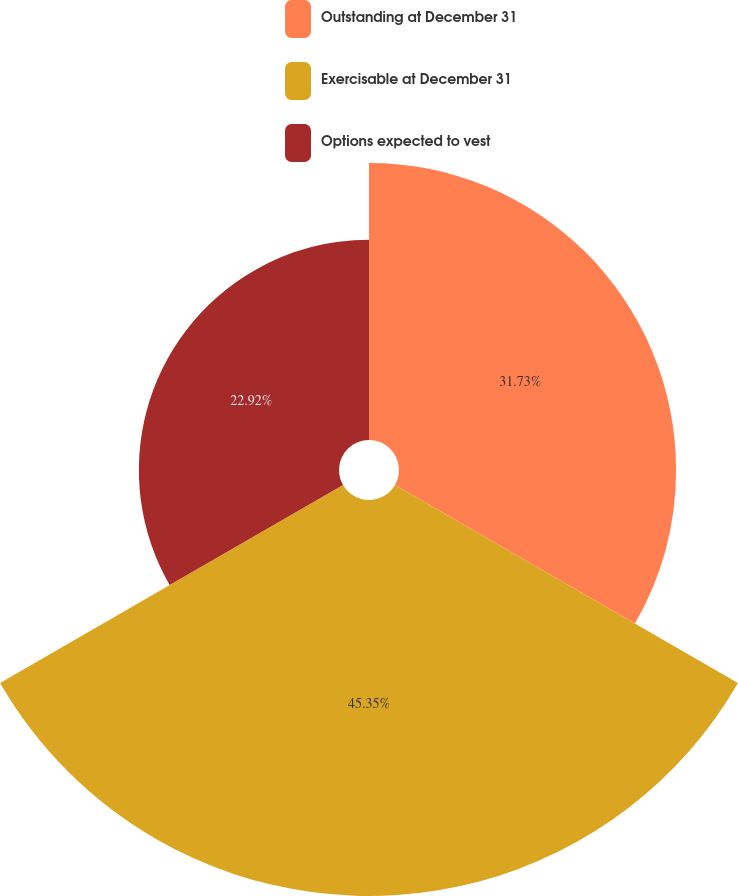Convert chart to OTSL. <chart><loc_0><loc_0><loc_500><loc_500><pie_chart><fcel>Outstanding at December 31<fcel>Exercisable at December 31<fcel>Options expected to vest<nl><fcel>31.73%<fcel>45.35%<fcel>22.92%<nl></chart> 